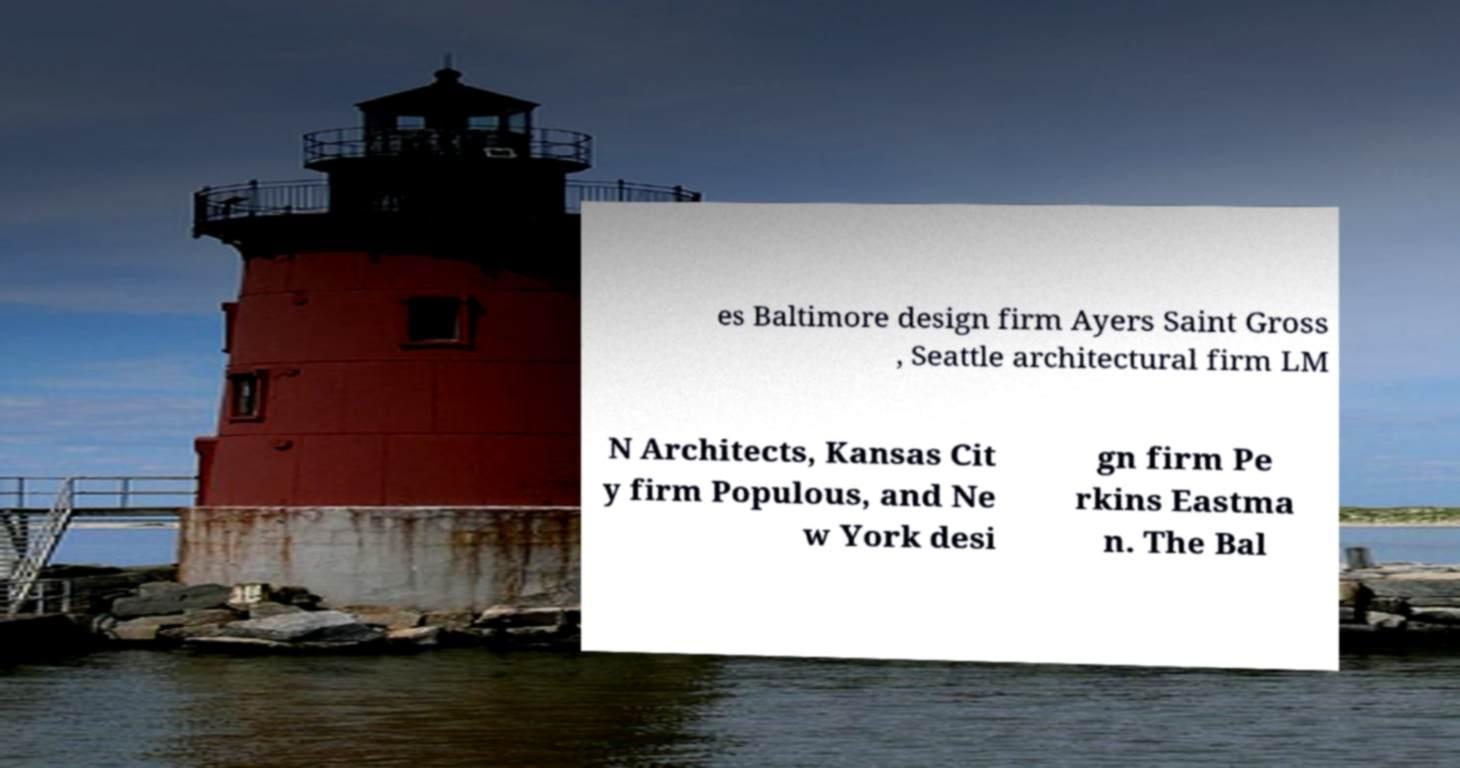Can you read and provide the text displayed in the image?This photo seems to have some interesting text. Can you extract and type it out for me? es Baltimore design firm Ayers Saint Gross , Seattle architectural firm LM N Architects, Kansas Cit y firm Populous, and Ne w York desi gn firm Pe rkins Eastma n. The Bal 